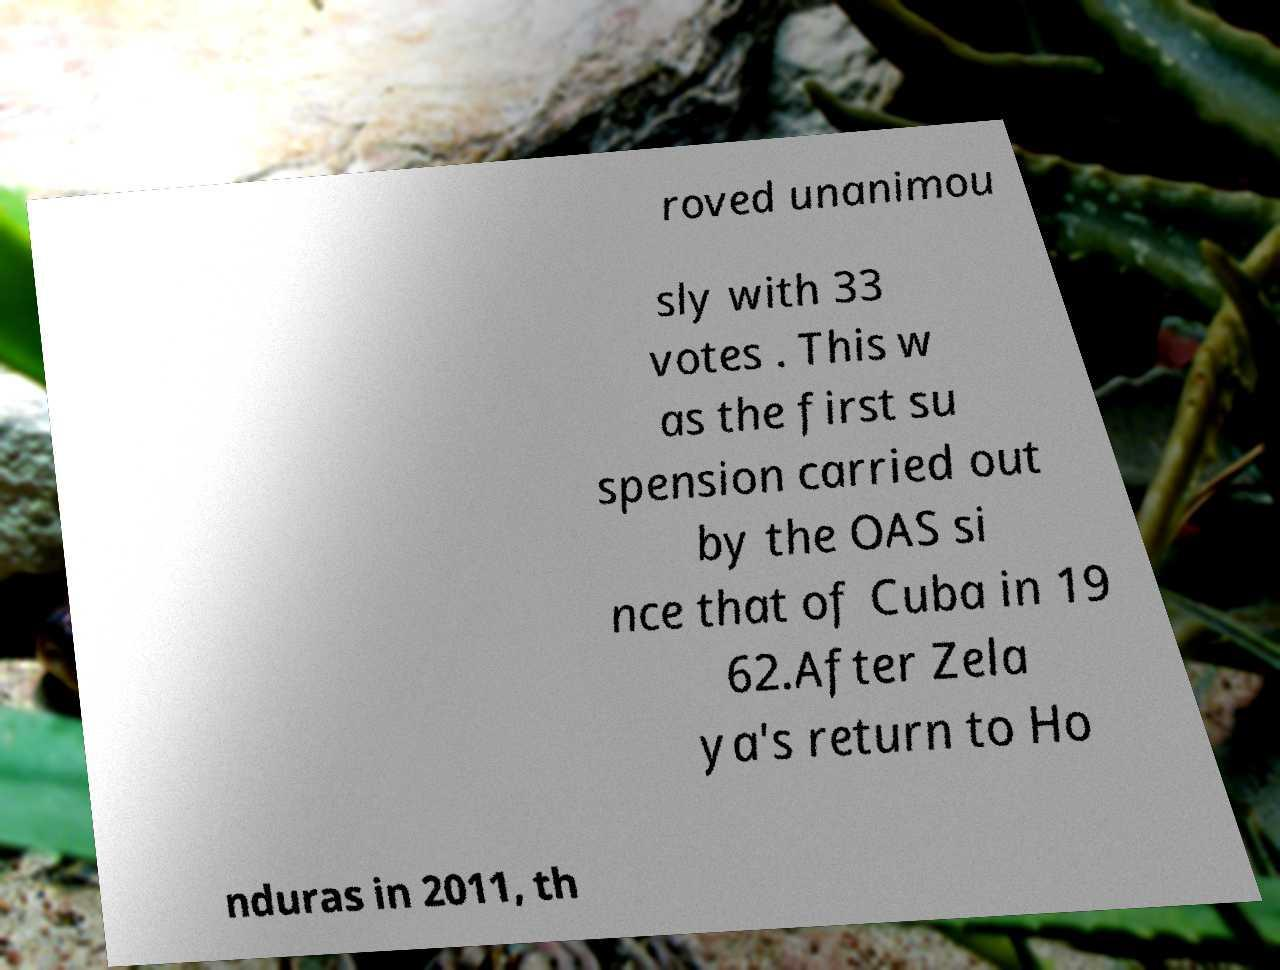What messages or text are displayed in this image? I need them in a readable, typed format. roved unanimou sly with 33 votes . This w as the first su spension carried out by the OAS si nce that of Cuba in 19 62.After Zela ya's return to Ho nduras in 2011, th 